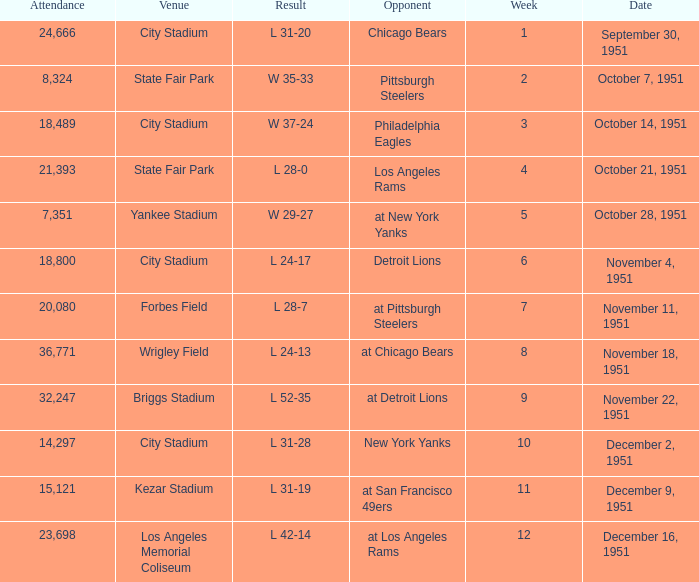Which venue hosted the Los Angeles Rams as an opponent? State Fair Park. 